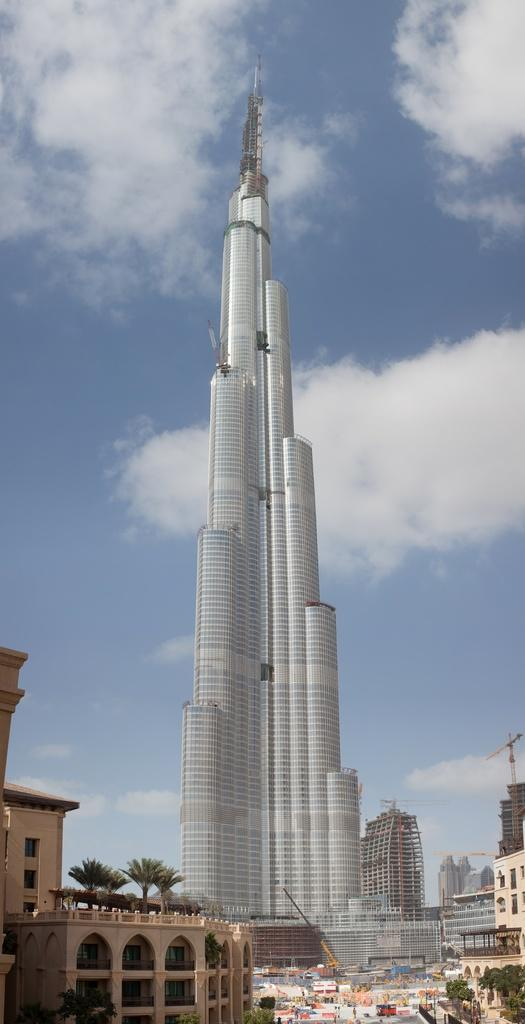What type of structures can be seen in the image? There are multiple buildings in the image, including the Burj Khalifa. What is the condition of the vegetation in the image? There are trees on both sides of the image. What can be seen in the background of the image? There are clouds and the sky visible in the background of the image. What type of knee injury is visible in the image? There is no knee injury present in the image; it features multiple buildings, trees, clouds, and the sky. 